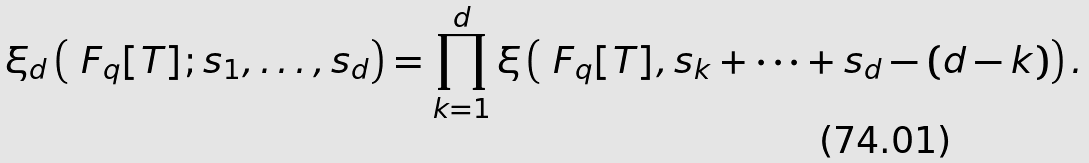Convert formula to latex. <formula><loc_0><loc_0><loc_500><loc_500>\xi _ { d } \left ( \ F _ { q } [ T ] ; s _ { 1 } , \dots , s _ { d } \right ) & = \prod _ { k = 1 } ^ { d } \xi \left ( \ F _ { q } [ T ] , s _ { k } + \cdots + s _ { d } - ( d - k ) \right ) .</formula> 